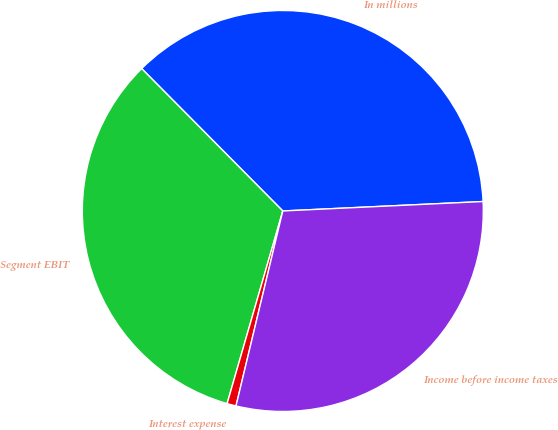Convert chart. <chart><loc_0><loc_0><loc_500><loc_500><pie_chart><fcel>In millions<fcel>Segment EBIT<fcel>Interest expense<fcel>Income before income taxes<nl><fcel>36.68%<fcel>33.09%<fcel>0.73%<fcel>29.5%<nl></chart> 